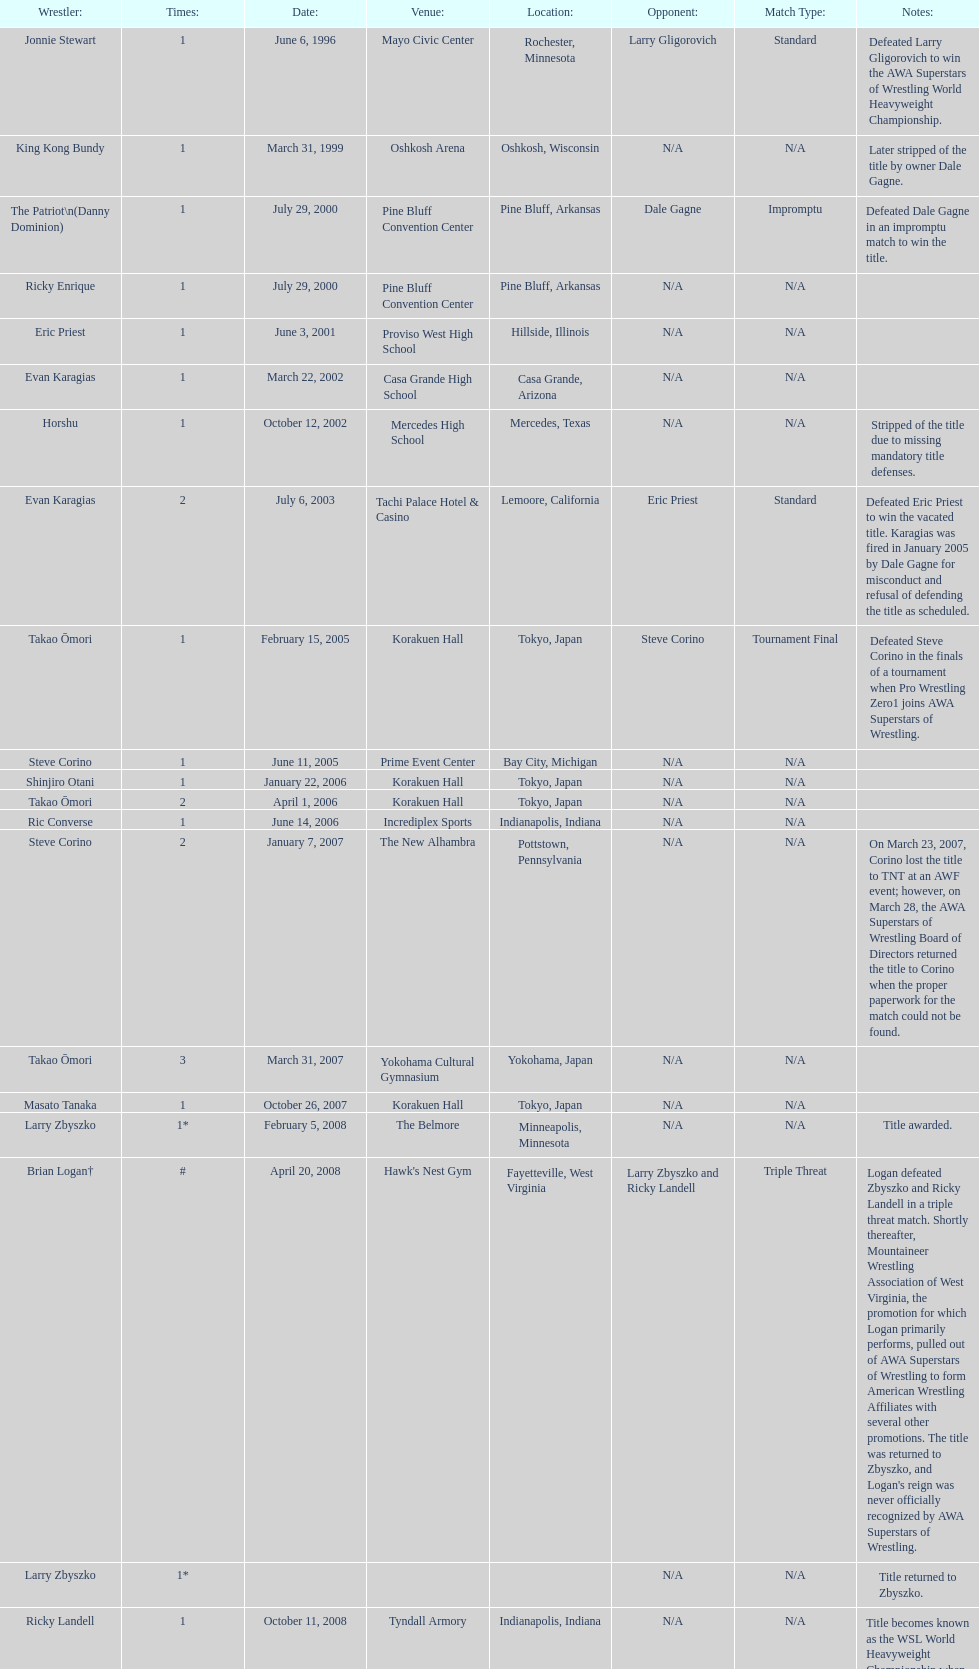Who is the only wsl title holder from texas? Horshu. 